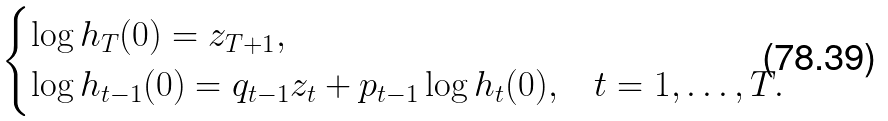<formula> <loc_0><loc_0><loc_500><loc_500>\begin{cases} \log h _ { T } ( 0 ) = z _ { T + 1 } , & \\ \log h _ { t - 1 } ( 0 ) = q _ { t - 1 } z _ { t } + p _ { t - 1 } \log h _ { t } ( 0 ) , & t = 1 , \dots , T . \end{cases}</formula> 